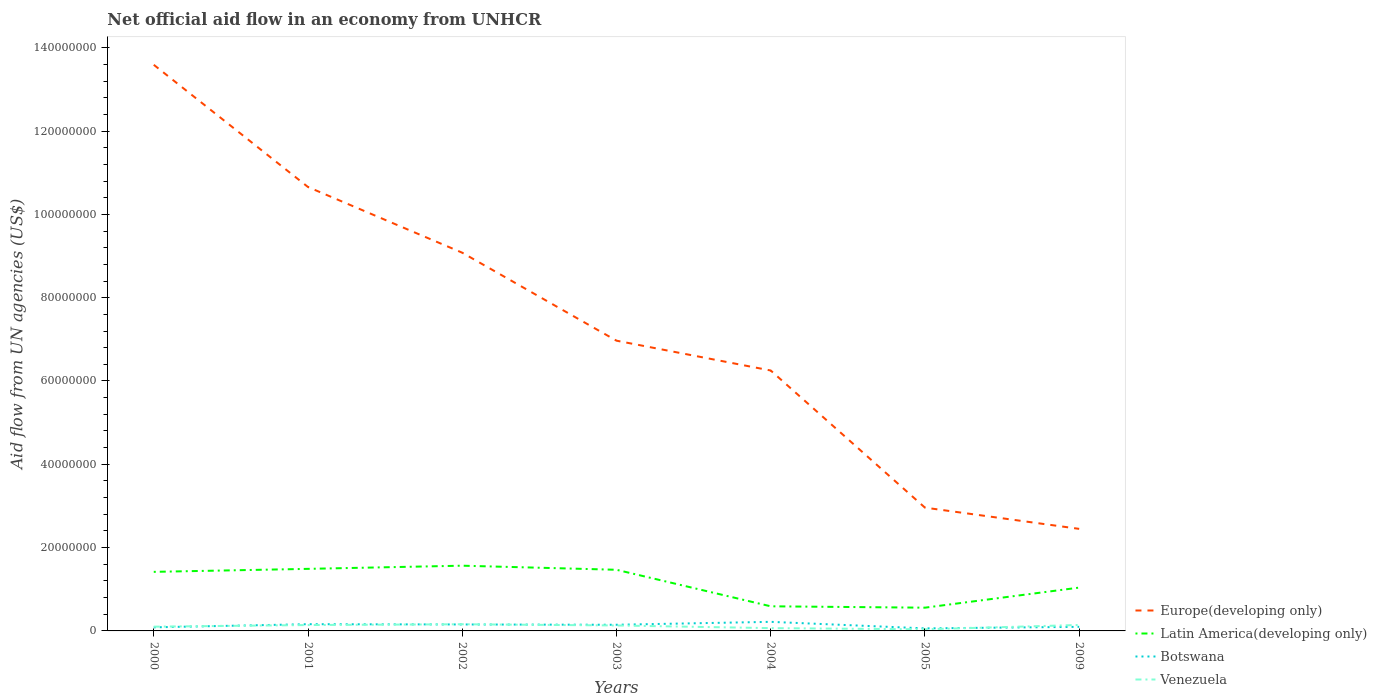How many different coloured lines are there?
Give a very brief answer. 4. Is the number of lines equal to the number of legend labels?
Provide a succinct answer. Yes. What is the total net official aid flow in Venezuela in the graph?
Ensure brevity in your answer.  1.21e+06. What is the difference between the highest and the second highest net official aid flow in Europe(developing only)?
Provide a short and direct response. 1.11e+08. What is the difference between the highest and the lowest net official aid flow in Europe(developing only)?
Offer a very short reply. 3. How many lines are there?
Provide a succinct answer. 4. What is the difference between two consecutive major ticks on the Y-axis?
Make the answer very short. 2.00e+07. Are the values on the major ticks of Y-axis written in scientific E-notation?
Make the answer very short. No. Does the graph contain any zero values?
Your answer should be compact. No. Does the graph contain grids?
Offer a very short reply. No. Where does the legend appear in the graph?
Ensure brevity in your answer.  Bottom right. How many legend labels are there?
Make the answer very short. 4. What is the title of the graph?
Your response must be concise. Net official aid flow in an economy from UNHCR. Does "Uzbekistan" appear as one of the legend labels in the graph?
Provide a succinct answer. No. What is the label or title of the X-axis?
Offer a very short reply. Years. What is the label or title of the Y-axis?
Keep it short and to the point. Aid flow from UN agencies (US$). What is the Aid flow from UN agencies (US$) of Europe(developing only) in 2000?
Your answer should be compact. 1.36e+08. What is the Aid flow from UN agencies (US$) of Latin America(developing only) in 2000?
Offer a very short reply. 1.42e+07. What is the Aid flow from UN agencies (US$) in Botswana in 2000?
Your answer should be compact. 8.60e+05. What is the Aid flow from UN agencies (US$) of Venezuela in 2000?
Keep it short and to the point. 1.02e+06. What is the Aid flow from UN agencies (US$) of Europe(developing only) in 2001?
Offer a terse response. 1.07e+08. What is the Aid flow from UN agencies (US$) in Latin America(developing only) in 2001?
Offer a very short reply. 1.49e+07. What is the Aid flow from UN agencies (US$) in Botswana in 2001?
Your response must be concise. 1.62e+06. What is the Aid flow from UN agencies (US$) of Venezuela in 2001?
Your response must be concise. 1.41e+06. What is the Aid flow from UN agencies (US$) in Europe(developing only) in 2002?
Make the answer very short. 9.08e+07. What is the Aid flow from UN agencies (US$) in Latin America(developing only) in 2002?
Offer a terse response. 1.57e+07. What is the Aid flow from UN agencies (US$) in Botswana in 2002?
Ensure brevity in your answer.  1.55e+06. What is the Aid flow from UN agencies (US$) of Venezuela in 2002?
Ensure brevity in your answer.  1.60e+06. What is the Aid flow from UN agencies (US$) of Europe(developing only) in 2003?
Your answer should be very brief. 6.97e+07. What is the Aid flow from UN agencies (US$) of Latin America(developing only) in 2003?
Keep it short and to the point. 1.47e+07. What is the Aid flow from UN agencies (US$) of Botswana in 2003?
Ensure brevity in your answer.  1.48e+06. What is the Aid flow from UN agencies (US$) in Venezuela in 2003?
Offer a very short reply. 1.31e+06. What is the Aid flow from UN agencies (US$) of Europe(developing only) in 2004?
Give a very brief answer. 6.25e+07. What is the Aid flow from UN agencies (US$) in Latin America(developing only) in 2004?
Offer a terse response. 5.91e+06. What is the Aid flow from UN agencies (US$) in Botswana in 2004?
Give a very brief answer. 2.18e+06. What is the Aid flow from UN agencies (US$) in Venezuela in 2004?
Provide a short and direct response. 6.70e+05. What is the Aid flow from UN agencies (US$) in Europe(developing only) in 2005?
Keep it short and to the point. 2.96e+07. What is the Aid flow from UN agencies (US$) in Latin America(developing only) in 2005?
Provide a succinct answer. 5.58e+06. What is the Aid flow from UN agencies (US$) of Europe(developing only) in 2009?
Your answer should be very brief. 2.45e+07. What is the Aid flow from UN agencies (US$) of Latin America(developing only) in 2009?
Provide a succinct answer. 1.04e+07. What is the Aid flow from UN agencies (US$) in Botswana in 2009?
Provide a short and direct response. 9.80e+05. What is the Aid flow from UN agencies (US$) in Venezuela in 2009?
Ensure brevity in your answer.  1.43e+06. Across all years, what is the maximum Aid flow from UN agencies (US$) in Europe(developing only)?
Your answer should be compact. 1.36e+08. Across all years, what is the maximum Aid flow from UN agencies (US$) of Latin America(developing only)?
Ensure brevity in your answer.  1.57e+07. Across all years, what is the maximum Aid flow from UN agencies (US$) of Botswana?
Keep it short and to the point. 2.18e+06. Across all years, what is the maximum Aid flow from UN agencies (US$) in Venezuela?
Provide a succinct answer. 1.60e+06. Across all years, what is the minimum Aid flow from UN agencies (US$) of Europe(developing only)?
Provide a succinct answer. 2.45e+07. Across all years, what is the minimum Aid flow from UN agencies (US$) in Latin America(developing only)?
Provide a succinct answer. 5.58e+06. Across all years, what is the minimum Aid flow from UN agencies (US$) in Botswana?
Keep it short and to the point. 6.10e+05. What is the total Aid flow from UN agencies (US$) in Europe(developing only) in the graph?
Provide a short and direct response. 5.20e+08. What is the total Aid flow from UN agencies (US$) in Latin America(developing only) in the graph?
Your answer should be very brief. 8.13e+07. What is the total Aid flow from UN agencies (US$) in Botswana in the graph?
Offer a terse response. 9.28e+06. What is the total Aid flow from UN agencies (US$) of Venezuela in the graph?
Provide a short and direct response. 7.83e+06. What is the difference between the Aid flow from UN agencies (US$) in Europe(developing only) in 2000 and that in 2001?
Offer a terse response. 2.93e+07. What is the difference between the Aid flow from UN agencies (US$) of Latin America(developing only) in 2000 and that in 2001?
Your response must be concise. -7.20e+05. What is the difference between the Aid flow from UN agencies (US$) of Botswana in 2000 and that in 2001?
Offer a terse response. -7.60e+05. What is the difference between the Aid flow from UN agencies (US$) in Venezuela in 2000 and that in 2001?
Offer a very short reply. -3.90e+05. What is the difference between the Aid flow from UN agencies (US$) in Europe(developing only) in 2000 and that in 2002?
Your response must be concise. 4.51e+07. What is the difference between the Aid flow from UN agencies (US$) of Latin America(developing only) in 2000 and that in 2002?
Provide a succinct answer. -1.48e+06. What is the difference between the Aid flow from UN agencies (US$) of Botswana in 2000 and that in 2002?
Make the answer very short. -6.90e+05. What is the difference between the Aid flow from UN agencies (US$) in Venezuela in 2000 and that in 2002?
Ensure brevity in your answer.  -5.80e+05. What is the difference between the Aid flow from UN agencies (US$) in Europe(developing only) in 2000 and that in 2003?
Offer a terse response. 6.62e+07. What is the difference between the Aid flow from UN agencies (US$) in Latin America(developing only) in 2000 and that in 2003?
Give a very brief answer. -5.00e+05. What is the difference between the Aid flow from UN agencies (US$) in Botswana in 2000 and that in 2003?
Provide a short and direct response. -6.20e+05. What is the difference between the Aid flow from UN agencies (US$) of Europe(developing only) in 2000 and that in 2004?
Make the answer very short. 7.34e+07. What is the difference between the Aid flow from UN agencies (US$) in Latin America(developing only) in 2000 and that in 2004?
Provide a succinct answer. 8.27e+06. What is the difference between the Aid flow from UN agencies (US$) in Botswana in 2000 and that in 2004?
Provide a succinct answer. -1.32e+06. What is the difference between the Aid flow from UN agencies (US$) in Venezuela in 2000 and that in 2004?
Provide a succinct answer. 3.50e+05. What is the difference between the Aid flow from UN agencies (US$) of Europe(developing only) in 2000 and that in 2005?
Offer a terse response. 1.06e+08. What is the difference between the Aid flow from UN agencies (US$) of Latin America(developing only) in 2000 and that in 2005?
Your answer should be very brief. 8.60e+06. What is the difference between the Aid flow from UN agencies (US$) in Botswana in 2000 and that in 2005?
Keep it short and to the point. 2.50e+05. What is the difference between the Aid flow from UN agencies (US$) in Venezuela in 2000 and that in 2005?
Your answer should be very brief. 6.30e+05. What is the difference between the Aid flow from UN agencies (US$) in Europe(developing only) in 2000 and that in 2009?
Your answer should be compact. 1.11e+08. What is the difference between the Aid flow from UN agencies (US$) in Latin America(developing only) in 2000 and that in 2009?
Your answer should be compact. 3.78e+06. What is the difference between the Aid flow from UN agencies (US$) in Venezuela in 2000 and that in 2009?
Provide a short and direct response. -4.10e+05. What is the difference between the Aid flow from UN agencies (US$) of Europe(developing only) in 2001 and that in 2002?
Provide a short and direct response. 1.58e+07. What is the difference between the Aid flow from UN agencies (US$) of Latin America(developing only) in 2001 and that in 2002?
Your response must be concise. -7.60e+05. What is the difference between the Aid flow from UN agencies (US$) in Botswana in 2001 and that in 2002?
Provide a short and direct response. 7.00e+04. What is the difference between the Aid flow from UN agencies (US$) of Europe(developing only) in 2001 and that in 2003?
Make the answer very short. 3.69e+07. What is the difference between the Aid flow from UN agencies (US$) in Latin America(developing only) in 2001 and that in 2003?
Provide a short and direct response. 2.20e+05. What is the difference between the Aid flow from UN agencies (US$) of Botswana in 2001 and that in 2003?
Provide a succinct answer. 1.40e+05. What is the difference between the Aid flow from UN agencies (US$) of Europe(developing only) in 2001 and that in 2004?
Ensure brevity in your answer.  4.40e+07. What is the difference between the Aid flow from UN agencies (US$) of Latin America(developing only) in 2001 and that in 2004?
Provide a short and direct response. 8.99e+06. What is the difference between the Aid flow from UN agencies (US$) of Botswana in 2001 and that in 2004?
Your response must be concise. -5.60e+05. What is the difference between the Aid flow from UN agencies (US$) of Venezuela in 2001 and that in 2004?
Offer a very short reply. 7.40e+05. What is the difference between the Aid flow from UN agencies (US$) of Europe(developing only) in 2001 and that in 2005?
Ensure brevity in your answer.  7.70e+07. What is the difference between the Aid flow from UN agencies (US$) of Latin America(developing only) in 2001 and that in 2005?
Ensure brevity in your answer.  9.32e+06. What is the difference between the Aid flow from UN agencies (US$) in Botswana in 2001 and that in 2005?
Provide a short and direct response. 1.01e+06. What is the difference between the Aid flow from UN agencies (US$) in Venezuela in 2001 and that in 2005?
Ensure brevity in your answer.  1.02e+06. What is the difference between the Aid flow from UN agencies (US$) of Europe(developing only) in 2001 and that in 2009?
Offer a very short reply. 8.21e+07. What is the difference between the Aid flow from UN agencies (US$) of Latin America(developing only) in 2001 and that in 2009?
Your answer should be very brief. 4.50e+06. What is the difference between the Aid flow from UN agencies (US$) in Botswana in 2001 and that in 2009?
Offer a very short reply. 6.40e+05. What is the difference between the Aid flow from UN agencies (US$) in Europe(developing only) in 2002 and that in 2003?
Provide a short and direct response. 2.11e+07. What is the difference between the Aid flow from UN agencies (US$) of Latin America(developing only) in 2002 and that in 2003?
Your response must be concise. 9.80e+05. What is the difference between the Aid flow from UN agencies (US$) in Botswana in 2002 and that in 2003?
Give a very brief answer. 7.00e+04. What is the difference between the Aid flow from UN agencies (US$) in Europe(developing only) in 2002 and that in 2004?
Keep it short and to the point. 2.83e+07. What is the difference between the Aid flow from UN agencies (US$) of Latin America(developing only) in 2002 and that in 2004?
Your response must be concise. 9.75e+06. What is the difference between the Aid flow from UN agencies (US$) of Botswana in 2002 and that in 2004?
Provide a short and direct response. -6.30e+05. What is the difference between the Aid flow from UN agencies (US$) of Venezuela in 2002 and that in 2004?
Your answer should be very brief. 9.30e+05. What is the difference between the Aid flow from UN agencies (US$) of Europe(developing only) in 2002 and that in 2005?
Your answer should be very brief. 6.12e+07. What is the difference between the Aid flow from UN agencies (US$) in Latin America(developing only) in 2002 and that in 2005?
Your answer should be very brief. 1.01e+07. What is the difference between the Aid flow from UN agencies (US$) in Botswana in 2002 and that in 2005?
Your answer should be very brief. 9.40e+05. What is the difference between the Aid flow from UN agencies (US$) of Venezuela in 2002 and that in 2005?
Provide a succinct answer. 1.21e+06. What is the difference between the Aid flow from UN agencies (US$) in Europe(developing only) in 2002 and that in 2009?
Provide a short and direct response. 6.63e+07. What is the difference between the Aid flow from UN agencies (US$) in Latin America(developing only) in 2002 and that in 2009?
Make the answer very short. 5.26e+06. What is the difference between the Aid flow from UN agencies (US$) in Botswana in 2002 and that in 2009?
Provide a short and direct response. 5.70e+05. What is the difference between the Aid flow from UN agencies (US$) of Venezuela in 2002 and that in 2009?
Your answer should be very brief. 1.70e+05. What is the difference between the Aid flow from UN agencies (US$) in Europe(developing only) in 2003 and that in 2004?
Offer a very short reply. 7.16e+06. What is the difference between the Aid flow from UN agencies (US$) of Latin America(developing only) in 2003 and that in 2004?
Make the answer very short. 8.77e+06. What is the difference between the Aid flow from UN agencies (US$) of Botswana in 2003 and that in 2004?
Your answer should be compact. -7.00e+05. What is the difference between the Aid flow from UN agencies (US$) in Venezuela in 2003 and that in 2004?
Offer a terse response. 6.40e+05. What is the difference between the Aid flow from UN agencies (US$) in Europe(developing only) in 2003 and that in 2005?
Offer a terse response. 4.01e+07. What is the difference between the Aid flow from UN agencies (US$) of Latin America(developing only) in 2003 and that in 2005?
Provide a short and direct response. 9.10e+06. What is the difference between the Aid flow from UN agencies (US$) in Botswana in 2003 and that in 2005?
Make the answer very short. 8.70e+05. What is the difference between the Aid flow from UN agencies (US$) in Venezuela in 2003 and that in 2005?
Make the answer very short. 9.20e+05. What is the difference between the Aid flow from UN agencies (US$) of Europe(developing only) in 2003 and that in 2009?
Your answer should be very brief. 4.52e+07. What is the difference between the Aid flow from UN agencies (US$) in Latin America(developing only) in 2003 and that in 2009?
Give a very brief answer. 4.28e+06. What is the difference between the Aid flow from UN agencies (US$) of Botswana in 2003 and that in 2009?
Your answer should be very brief. 5.00e+05. What is the difference between the Aid flow from UN agencies (US$) of Europe(developing only) in 2004 and that in 2005?
Offer a terse response. 3.29e+07. What is the difference between the Aid flow from UN agencies (US$) in Botswana in 2004 and that in 2005?
Keep it short and to the point. 1.57e+06. What is the difference between the Aid flow from UN agencies (US$) in Europe(developing only) in 2004 and that in 2009?
Give a very brief answer. 3.80e+07. What is the difference between the Aid flow from UN agencies (US$) of Latin America(developing only) in 2004 and that in 2009?
Your response must be concise. -4.49e+06. What is the difference between the Aid flow from UN agencies (US$) in Botswana in 2004 and that in 2009?
Your response must be concise. 1.20e+06. What is the difference between the Aid flow from UN agencies (US$) of Venezuela in 2004 and that in 2009?
Make the answer very short. -7.60e+05. What is the difference between the Aid flow from UN agencies (US$) of Europe(developing only) in 2005 and that in 2009?
Provide a short and direct response. 5.10e+06. What is the difference between the Aid flow from UN agencies (US$) in Latin America(developing only) in 2005 and that in 2009?
Give a very brief answer. -4.82e+06. What is the difference between the Aid flow from UN agencies (US$) in Botswana in 2005 and that in 2009?
Your answer should be compact. -3.70e+05. What is the difference between the Aid flow from UN agencies (US$) in Venezuela in 2005 and that in 2009?
Provide a succinct answer. -1.04e+06. What is the difference between the Aid flow from UN agencies (US$) of Europe(developing only) in 2000 and the Aid flow from UN agencies (US$) of Latin America(developing only) in 2001?
Make the answer very short. 1.21e+08. What is the difference between the Aid flow from UN agencies (US$) in Europe(developing only) in 2000 and the Aid flow from UN agencies (US$) in Botswana in 2001?
Ensure brevity in your answer.  1.34e+08. What is the difference between the Aid flow from UN agencies (US$) in Europe(developing only) in 2000 and the Aid flow from UN agencies (US$) in Venezuela in 2001?
Your response must be concise. 1.34e+08. What is the difference between the Aid flow from UN agencies (US$) in Latin America(developing only) in 2000 and the Aid flow from UN agencies (US$) in Botswana in 2001?
Provide a succinct answer. 1.26e+07. What is the difference between the Aid flow from UN agencies (US$) in Latin America(developing only) in 2000 and the Aid flow from UN agencies (US$) in Venezuela in 2001?
Keep it short and to the point. 1.28e+07. What is the difference between the Aid flow from UN agencies (US$) of Botswana in 2000 and the Aid flow from UN agencies (US$) of Venezuela in 2001?
Your answer should be very brief. -5.50e+05. What is the difference between the Aid flow from UN agencies (US$) in Europe(developing only) in 2000 and the Aid flow from UN agencies (US$) in Latin America(developing only) in 2002?
Offer a terse response. 1.20e+08. What is the difference between the Aid flow from UN agencies (US$) in Europe(developing only) in 2000 and the Aid flow from UN agencies (US$) in Botswana in 2002?
Give a very brief answer. 1.34e+08. What is the difference between the Aid flow from UN agencies (US$) of Europe(developing only) in 2000 and the Aid flow from UN agencies (US$) of Venezuela in 2002?
Keep it short and to the point. 1.34e+08. What is the difference between the Aid flow from UN agencies (US$) of Latin America(developing only) in 2000 and the Aid flow from UN agencies (US$) of Botswana in 2002?
Your response must be concise. 1.26e+07. What is the difference between the Aid flow from UN agencies (US$) of Latin America(developing only) in 2000 and the Aid flow from UN agencies (US$) of Venezuela in 2002?
Your response must be concise. 1.26e+07. What is the difference between the Aid flow from UN agencies (US$) of Botswana in 2000 and the Aid flow from UN agencies (US$) of Venezuela in 2002?
Give a very brief answer. -7.40e+05. What is the difference between the Aid flow from UN agencies (US$) in Europe(developing only) in 2000 and the Aid flow from UN agencies (US$) in Latin America(developing only) in 2003?
Offer a terse response. 1.21e+08. What is the difference between the Aid flow from UN agencies (US$) of Europe(developing only) in 2000 and the Aid flow from UN agencies (US$) of Botswana in 2003?
Provide a short and direct response. 1.34e+08. What is the difference between the Aid flow from UN agencies (US$) in Europe(developing only) in 2000 and the Aid flow from UN agencies (US$) in Venezuela in 2003?
Ensure brevity in your answer.  1.35e+08. What is the difference between the Aid flow from UN agencies (US$) of Latin America(developing only) in 2000 and the Aid flow from UN agencies (US$) of Botswana in 2003?
Your answer should be very brief. 1.27e+07. What is the difference between the Aid flow from UN agencies (US$) in Latin America(developing only) in 2000 and the Aid flow from UN agencies (US$) in Venezuela in 2003?
Offer a terse response. 1.29e+07. What is the difference between the Aid flow from UN agencies (US$) of Botswana in 2000 and the Aid flow from UN agencies (US$) of Venezuela in 2003?
Your response must be concise. -4.50e+05. What is the difference between the Aid flow from UN agencies (US$) in Europe(developing only) in 2000 and the Aid flow from UN agencies (US$) in Latin America(developing only) in 2004?
Your response must be concise. 1.30e+08. What is the difference between the Aid flow from UN agencies (US$) in Europe(developing only) in 2000 and the Aid flow from UN agencies (US$) in Botswana in 2004?
Make the answer very short. 1.34e+08. What is the difference between the Aid flow from UN agencies (US$) of Europe(developing only) in 2000 and the Aid flow from UN agencies (US$) of Venezuela in 2004?
Ensure brevity in your answer.  1.35e+08. What is the difference between the Aid flow from UN agencies (US$) of Latin America(developing only) in 2000 and the Aid flow from UN agencies (US$) of Venezuela in 2004?
Provide a succinct answer. 1.35e+07. What is the difference between the Aid flow from UN agencies (US$) of Botswana in 2000 and the Aid flow from UN agencies (US$) of Venezuela in 2004?
Offer a terse response. 1.90e+05. What is the difference between the Aid flow from UN agencies (US$) of Europe(developing only) in 2000 and the Aid flow from UN agencies (US$) of Latin America(developing only) in 2005?
Your answer should be compact. 1.30e+08. What is the difference between the Aid flow from UN agencies (US$) of Europe(developing only) in 2000 and the Aid flow from UN agencies (US$) of Botswana in 2005?
Your answer should be compact. 1.35e+08. What is the difference between the Aid flow from UN agencies (US$) of Europe(developing only) in 2000 and the Aid flow from UN agencies (US$) of Venezuela in 2005?
Offer a terse response. 1.36e+08. What is the difference between the Aid flow from UN agencies (US$) of Latin America(developing only) in 2000 and the Aid flow from UN agencies (US$) of Botswana in 2005?
Your response must be concise. 1.36e+07. What is the difference between the Aid flow from UN agencies (US$) in Latin America(developing only) in 2000 and the Aid flow from UN agencies (US$) in Venezuela in 2005?
Ensure brevity in your answer.  1.38e+07. What is the difference between the Aid flow from UN agencies (US$) in Europe(developing only) in 2000 and the Aid flow from UN agencies (US$) in Latin America(developing only) in 2009?
Your response must be concise. 1.26e+08. What is the difference between the Aid flow from UN agencies (US$) of Europe(developing only) in 2000 and the Aid flow from UN agencies (US$) of Botswana in 2009?
Give a very brief answer. 1.35e+08. What is the difference between the Aid flow from UN agencies (US$) of Europe(developing only) in 2000 and the Aid flow from UN agencies (US$) of Venezuela in 2009?
Provide a succinct answer. 1.34e+08. What is the difference between the Aid flow from UN agencies (US$) in Latin America(developing only) in 2000 and the Aid flow from UN agencies (US$) in Botswana in 2009?
Offer a very short reply. 1.32e+07. What is the difference between the Aid flow from UN agencies (US$) of Latin America(developing only) in 2000 and the Aid flow from UN agencies (US$) of Venezuela in 2009?
Give a very brief answer. 1.28e+07. What is the difference between the Aid flow from UN agencies (US$) of Botswana in 2000 and the Aid flow from UN agencies (US$) of Venezuela in 2009?
Keep it short and to the point. -5.70e+05. What is the difference between the Aid flow from UN agencies (US$) of Europe(developing only) in 2001 and the Aid flow from UN agencies (US$) of Latin America(developing only) in 2002?
Provide a succinct answer. 9.09e+07. What is the difference between the Aid flow from UN agencies (US$) of Europe(developing only) in 2001 and the Aid flow from UN agencies (US$) of Botswana in 2002?
Give a very brief answer. 1.05e+08. What is the difference between the Aid flow from UN agencies (US$) of Europe(developing only) in 2001 and the Aid flow from UN agencies (US$) of Venezuela in 2002?
Give a very brief answer. 1.05e+08. What is the difference between the Aid flow from UN agencies (US$) of Latin America(developing only) in 2001 and the Aid flow from UN agencies (US$) of Botswana in 2002?
Ensure brevity in your answer.  1.34e+07. What is the difference between the Aid flow from UN agencies (US$) of Latin America(developing only) in 2001 and the Aid flow from UN agencies (US$) of Venezuela in 2002?
Offer a terse response. 1.33e+07. What is the difference between the Aid flow from UN agencies (US$) of Europe(developing only) in 2001 and the Aid flow from UN agencies (US$) of Latin America(developing only) in 2003?
Offer a very short reply. 9.19e+07. What is the difference between the Aid flow from UN agencies (US$) of Europe(developing only) in 2001 and the Aid flow from UN agencies (US$) of Botswana in 2003?
Offer a very short reply. 1.05e+08. What is the difference between the Aid flow from UN agencies (US$) of Europe(developing only) in 2001 and the Aid flow from UN agencies (US$) of Venezuela in 2003?
Offer a terse response. 1.05e+08. What is the difference between the Aid flow from UN agencies (US$) of Latin America(developing only) in 2001 and the Aid flow from UN agencies (US$) of Botswana in 2003?
Ensure brevity in your answer.  1.34e+07. What is the difference between the Aid flow from UN agencies (US$) of Latin America(developing only) in 2001 and the Aid flow from UN agencies (US$) of Venezuela in 2003?
Your answer should be compact. 1.36e+07. What is the difference between the Aid flow from UN agencies (US$) of Botswana in 2001 and the Aid flow from UN agencies (US$) of Venezuela in 2003?
Provide a succinct answer. 3.10e+05. What is the difference between the Aid flow from UN agencies (US$) in Europe(developing only) in 2001 and the Aid flow from UN agencies (US$) in Latin America(developing only) in 2004?
Your response must be concise. 1.01e+08. What is the difference between the Aid flow from UN agencies (US$) in Europe(developing only) in 2001 and the Aid flow from UN agencies (US$) in Botswana in 2004?
Provide a short and direct response. 1.04e+08. What is the difference between the Aid flow from UN agencies (US$) of Europe(developing only) in 2001 and the Aid flow from UN agencies (US$) of Venezuela in 2004?
Offer a very short reply. 1.06e+08. What is the difference between the Aid flow from UN agencies (US$) of Latin America(developing only) in 2001 and the Aid flow from UN agencies (US$) of Botswana in 2004?
Offer a terse response. 1.27e+07. What is the difference between the Aid flow from UN agencies (US$) of Latin America(developing only) in 2001 and the Aid flow from UN agencies (US$) of Venezuela in 2004?
Offer a terse response. 1.42e+07. What is the difference between the Aid flow from UN agencies (US$) in Botswana in 2001 and the Aid flow from UN agencies (US$) in Venezuela in 2004?
Provide a succinct answer. 9.50e+05. What is the difference between the Aid flow from UN agencies (US$) in Europe(developing only) in 2001 and the Aid flow from UN agencies (US$) in Latin America(developing only) in 2005?
Make the answer very short. 1.01e+08. What is the difference between the Aid flow from UN agencies (US$) of Europe(developing only) in 2001 and the Aid flow from UN agencies (US$) of Botswana in 2005?
Your response must be concise. 1.06e+08. What is the difference between the Aid flow from UN agencies (US$) of Europe(developing only) in 2001 and the Aid flow from UN agencies (US$) of Venezuela in 2005?
Offer a terse response. 1.06e+08. What is the difference between the Aid flow from UN agencies (US$) in Latin America(developing only) in 2001 and the Aid flow from UN agencies (US$) in Botswana in 2005?
Provide a succinct answer. 1.43e+07. What is the difference between the Aid flow from UN agencies (US$) of Latin America(developing only) in 2001 and the Aid flow from UN agencies (US$) of Venezuela in 2005?
Keep it short and to the point. 1.45e+07. What is the difference between the Aid flow from UN agencies (US$) in Botswana in 2001 and the Aid flow from UN agencies (US$) in Venezuela in 2005?
Ensure brevity in your answer.  1.23e+06. What is the difference between the Aid flow from UN agencies (US$) of Europe(developing only) in 2001 and the Aid flow from UN agencies (US$) of Latin America(developing only) in 2009?
Provide a succinct answer. 9.62e+07. What is the difference between the Aid flow from UN agencies (US$) in Europe(developing only) in 2001 and the Aid flow from UN agencies (US$) in Botswana in 2009?
Provide a succinct answer. 1.06e+08. What is the difference between the Aid flow from UN agencies (US$) of Europe(developing only) in 2001 and the Aid flow from UN agencies (US$) of Venezuela in 2009?
Your answer should be very brief. 1.05e+08. What is the difference between the Aid flow from UN agencies (US$) of Latin America(developing only) in 2001 and the Aid flow from UN agencies (US$) of Botswana in 2009?
Give a very brief answer. 1.39e+07. What is the difference between the Aid flow from UN agencies (US$) in Latin America(developing only) in 2001 and the Aid flow from UN agencies (US$) in Venezuela in 2009?
Offer a very short reply. 1.35e+07. What is the difference between the Aid flow from UN agencies (US$) of Europe(developing only) in 2002 and the Aid flow from UN agencies (US$) of Latin America(developing only) in 2003?
Your answer should be very brief. 7.61e+07. What is the difference between the Aid flow from UN agencies (US$) of Europe(developing only) in 2002 and the Aid flow from UN agencies (US$) of Botswana in 2003?
Provide a short and direct response. 8.93e+07. What is the difference between the Aid flow from UN agencies (US$) of Europe(developing only) in 2002 and the Aid flow from UN agencies (US$) of Venezuela in 2003?
Your response must be concise. 8.95e+07. What is the difference between the Aid flow from UN agencies (US$) in Latin America(developing only) in 2002 and the Aid flow from UN agencies (US$) in Botswana in 2003?
Make the answer very short. 1.42e+07. What is the difference between the Aid flow from UN agencies (US$) in Latin America(developing only) in 2002 and the Aid flow from UN agencies (US$) in Venezuela in 2003?
Provide a succinct answer. 1.44e+07. What is the difference between the Aid flow from UN agencies (US$) in Botswana in 2002 and the Aid flow from UN agencies (US$) in Venezuela in 2003?
Offer a terse response. 2.40e+05. What is the difference between the Aid flow from UN agencies (US$) in Europe(developing only) in 2002 and the Aid flow from UN agencies (US$) in Latin America(developing only) in 2004?
Offer a terse response. 8.49e+07. What is the difference between the Aid flow from UN agencies (US$) of Europe(developing only) in 2002 and the Aid flow from UN agencies (US$) of Botswana in 2004?
Make the answer very short. 8.86e+07. What is the difference between the Aid flow from UN agencies (US$) in Europe(developing only) in 2002 and the Aid flow from UN agencies (US$) in Venezuela in 2004?
Provide a short and direct response. 9.01e+07. What is the difference between the Aid flow from UN agencies (US$) of Latin America(developing only) in 2002 and the Aid flow from UN agencies (US$) of Botswana in 2004?
Your answer should be very brief. 1.35e+07. What is the difference between the Aid flow from UN agencies (US$) of Latin America(developing only) in 2002 and the Aid flow from UN agencies (US$) of Venezuela in 2004?
Give a very brief answer. 1.50e+07. What is the difference between the Aid flow from UN agencies (US$) in Botswana in 2002 and the Aid flow from UN agencies (US$) in Venezuela in 2004?
Your answer should be very brief. 8.80e+05. What is the difference between the Aid flow from UN agencies (US$) in Europe(developing only) in 2002 and the Aid flow from UN agencies (US$) in Latin America(developing only) in 2005?
Your answer should be compact. 8.52e+07. What is the difference between the Aid flow from UN agencies (US$) of Europe(developing only) in 2002 and the Aid flow from UN agencies (US$) of Botswana in 2005?
Ensure brevity in your answer.  9.02e+07. What is the difference between the Aid flow from UN agencies (US$) of Europe(developing only) in 2002 and the Aid flow from UN agencies (US$) of Venezuela in 2005?
Keep it short and to the point. 9.04e+07. What is the difference between the Aid flow from UN agencies (US$) in Latin America(developing only) in 2002 and the Aid flow from UN agencies (US$) in Botswana in 2005?
Give a very brief answer. 1.50e+07. What is the difference between the Aid flow from UN agencies (US$) of Latin America(developing only) in 2002 and the Aid flow from UN agencies (US$) of Venezuela in 2005?
Provide a short and direct response. 1.53e+07. What is the difference between the Aid flow from UN agencies (US$) in Botswana in 2002 and the Aid flow from UN agencies (US$) in Venezuela in 2005?
Provide a short and direct response. 1.16e+06. What is the difference between the Aid flow from UN agencies (US$) of Europe(developing only) in 2002 and the Aid flow from UN agencies (US$) of Latin America(developing only) in 2009?
Your answer should be very brief. 8.04e+07. What is the difference between the Aid flow from UN agencies (US$) of Europe(developing only) in 2002 and the Aid flow from UN agencies (US$) of Botswana in 2009?
Keep it short and to the point. 8.98e+07. What is the difference between the Aid flow from UN agencies (US$) in Europe(developing only) in 2002 and the Aid flow from UN agencies (US$) in Venezuela in 2009?
Provide a succinct answer. 8.94e+07. What is the difference between the Aid flow from UN agencies (US$) in Latin America(developing only) in 2002 and the Aid flow from UN agencies (US$) in Botswana in 2009?
Ensure brevity in your answer.  1.47e+07. What is the difference between the Aid flow from UN agencies (US$) in Latin America(developing only) in 2002 and the Aid flow from UN agencies (US$) in Venezuela in 2009?
Your response must be concise. 1.42e+07. What is the difference between the Aid flow from UN agencies (US$) of Botswana in 2002 and the Aid flow from UN agencies (US$) of Venezuela in 2009?
Give a very brief answer. 1.20e+05. What is the difference between the Aid flow from UN agencies (US$) of Europe(developing only) in 2003 and the Aid flow from UN agencies (US$) of Latin America(developing only) in 2004?
Make the answer very short. 6.38e+07. What is the difference between the Aid flow from UN agencies (US$) in Europe(developing only) in 2003 and the Aid flow from UN agencies (US$) in Botswana in 2004?
Ensure brevity in your answer.  6.75e+07. What is the difference between the Aid flow from UN agencies (US$) in Europe(developing only) in 2003 and the Aid flow from UN agencies (US$) in Venezuela in 2004?
Provide a short and direct response. 6.90e+07. What is the difference between the Aid flow from UN agencies (US$) in Latin America(developing only) in 2003 and the Aid flow from UN agencies (US$) in Botswana in 2004?
Ensure brevity in your answer.  1.25e+07. What is the difference between the Aid flow from UN agencies (US$) of Latin America(developing only) in 2003 and the Aid flow from UN agencies (US$) of Venezuela in 2004?
Provide a short and direct response. 1.40e+07. What is the difference between the Aid flow from UN agencies (US$) in Botswana in 2003 and the Aid flow from UN agencies (US$) in Venezuela in 2004?
Keep it short and to the point. 8.10e+05. What is the difference between the Aid flow from UN agencies (US$) of Europe(developing only) in 2003 and the Aid flow from UN agencies (US$) of Latin America(developing only) in 2005?
Offer a very short reply. 6.41e+07. What is the difference between the Aid flow from UN agencies (US$) in Europe(developing only) in 2003 and the Aid flow from UN agencies (US$) in Botswana in 2005?
Provide a succinct answer. 6.91e+07. What is the difference between the Aid flow from UN agencies (US$) of Europe(developing only) in 2003 and the Aid flow from UN agencies (US$) of Venezuela in 2005?
Keep it short and to the point. 6.93e+07. What is the difference between the Aid flow from UN agencies (US$) in Latin America(developing only) in 2003 and the Aid flow from UN agencies (US$) in Botswana in 2005?
Ensure brevity in your answer.  1.41e+07. What is the difference between the Aid flow from UN agencies (US$) of Latin America(developing only) in 2003 and the Aid flow from UN agencies (US$) of Venezuela in 2005?
Provide a succinct answer. 1.43e+07. What is the difference between the Aid flow from UN agencies (US$) in Botswana in 2003 and the Aid flow from UN agencies (US$) in Venezuela in 2005?
Your answer should be very brief. 1.09e+06. What is the difference between the Aid flow from UN agencies (US$) in Europe(developing only) in 2003 and the Aid flow from UN agencies (US$) in Latin America(developing only) in 2009?
Make the answer very short. 5.93e+07. What is the difference between the Aid flow from UN agencies (US$) of Europe(developing only) in 2003 and the Aid flow from UN agencies (US$) of Botswana in 2009?
Make the answer very short. 6.87e+07. What is the difference between the Aid flow from UN agencies (US$) in Europe(developing only) in 2003 and the Aid flow from UN agencies (US$) in Venezuela in 2009?
Provide a succinct answer. 6.82e+07. What is the difference between the Aid flow from UN agencies (US$) of Latin America(developing only) in 2003 and the Aid flow from UN agencies (US$) of Botswana in 2009?
Provide a short and direct response. 1.37e+07. What is the difference between the Aid flow from UN agencies (US$) of Latin America(developing only) in 2003 and the Aid flow from UN agencies (US$) of Venezuela in 2009?
Give a very brief answer. 1.32e+07. What is the difference between the Aid flow from UN agencies (US$) of Botswana in 2003 and the Aid flow from UN agencies (US$) of Venezuela in 2009?
Provide a short and direct response. 5.00e+04. What is the difference between the Aid flow from UN agencies (US$) in Europe(developing only) in 2004 and the Aid flow from UN agencies (US$) in Latin America(developing only) in 2005?
Offer a terse response. 5.69e+07. What is the difference between the Aid flow from UN agencies (US$) in Europe(developing only) in 2004 and the Aid flow from UN agencies (US$) in Botswana in 2005?
Give a very brief answer. 6.19e+07. What is the difference between the Aid flow from UN agencies (US$) of Europe(developing only) in 2004 and the Aid flow from UN agencies (US$) of Venezuela in 2005?
Your response must be concise. 6.21e+07. What is the difference between the Aid flow from UN agencies (US$) of Latin America(developing only) in 2004 and the Aid flow from UN agencies (US$) of Botswana in 2005?
Offer a terse response. 5.30e+06. What is the difference between the Aid flow from UN agencies (US$) of Latin America(developing only) in 2004 and the Aid flow from UN agencies (US$) of Venezuela in 2005?
Provide a succinct answer. 5.52e+06. What is the difference between the Aid flow from UN agencies (US$) in Botswana in 2004 and the Aid flow from UN agencies (US$) in Venezuela in 2005?
Make the answer very short. 1.79e+06. What is the difference between the Aid flow from UN agencies (US$) in Europe(developing only) in 2004 and the Aid flow from UN agencies (US$) in Latin America(developing only) in 2009?
Offer a terse response. 5.21e+07. What is the difference between the Aid flow from UN agencies (US$) of Europe(developing only) in 2004 and the Aid flow from UN agencies (US$) of Botswana in 2009?
Your answer should be very brief. 6.15e+07. What is the difference between the Aid flow from UN agencies (US$) in Europe(developing only) in 2004 and the Aid flow from UN agencies (US$) in Venezuela in 2009?
Offer a terse response. 6.11e+07. What is the difference between the Aid flow from UN agencies (US$) of Latin America(developing only) in 2004 and the Aid flow from UN agencies (US$) of Botswana in 2009?
Make the answer very short. 4.93e+06. What is the difference between the Aid flow from UN agencies (US$) of Latin America(developing only) in 2004 and the Aid flow from UN agencies (US$) of Venezuela in 2009?
Your answer should be compact. 4.48e+06. What is the difference between the Aid flow from UN agencies (US$) in Botswana in 2004 and the Aid flow from UN agencies (US$) in Venezuela in 2009?
Your answer should be compact. 7.50e+05. What is the difference between the Aid flow from UN agencies (US$) in Europe(developing only) in 2005 and the Aid flow from UN agencies (US$) in Latin America(developing only) in 2009?
Offer a very short reply. 1.92e+07. What is the difference between the Aid flow from UN agencies (US$) in Europe(developing only) in 2005 and the Aid flow from UN agencies (US$) in Botswana in 2009?
Give a very brief answer. 2.86e+07. What is the difference between the Aid flow from UN agencies (US$) of Europe(developing only) in 2005 and the Aid flow from UN agencies (US$) of Venezuela in 2009?
Offer a terse response. 2.82e+07. What is the difference between the Aid flow from UN agencies (US$) in Latin America(developing only) in 2005 and the Aid flow from UN agencies (US$) in Botswana in 2009?
Your answer should be compact. 4.60e+06. What is the difference between the Aid flow from UN agencies (US$) in Latin America(developing only) in 2005 and the Aid flow from UN agencies (US$) in Venezuela in 2009?
Offer a terse response. 4.15e+06. What is the difference between the Aid flow from UN agencies (US$) in Botswana in 2005 and the Aid flow from UN agencies (US$) in Venezuela in 2009?
Make the answer very short. -8.20e+05. What is the average Aid flow from UN agencies (US$) in Europe(developing only) per year?
Provide a short and direct response. 7.42e+07. What is the average Aid flow from UN agencies (US$) in Latin America(developing only) per year?
Your answer should be compact. 1.16e+07. What is the average Aid flow from UN agencies (US$) of Botswana per year?
Offer a terse response. 1.33e+06. What is the average Aid flow from UN agencies (US$) in Venezuela per year?
Your answer should be compact. 1.12e+06. In the year 2000, what is the difference between the Aid flow from UN agencies (US$) of Europe(developing only) and Aid flow from UN agencies (US$) of Latin America(developing only)?
Your answer should be compact. 1.22e+08. In the year 2000, what is the difference between the Aid flow from UN agencies (US$) of Europe(developing only) and Aid flow from UN agencies (US$) of Botswana?
Offer a very short reply. 1.35e+08. In the year 2000, what is the difference between the Aid flow from UN agencies (US$) of Europe(developing only) and Aid flow from UN agencies (US$) of Venezuela?
Keep it short and to the point. 1.35e+08. In the year 2000, what is the difference between the Aid flow from UN agencies (US$) of Latin America(developing only) and Aid flow from UN agencies (US$) of Botswana?
Offer a terse response. 1.33e+07. In the year 2000, what is the difference between the Aid flow from UN agencies (US$) in Latin America(developing only) and Aid flow from UN agencies (US$) in Venezuela?
Your answer should be very brief. 1.32e+07. In the year 2001, what is the difference between the Aid flow from UN agencies (US$) of Europe(developing only) and Aid flow from UN agencies (US$) of Latin America(developing only)?
Give a very brief answer. 9.17e+07. In the year 2001, what is the difference between the Aid flow from UN agencies (US$) of Europe(developing only) and Aid flow from UN agencies (US$) of Botswana?
Ensure brevity in your answer.  1.05e+08. In the year 2001, what is the difference between the Aid flow from UN agencies (US$) in Europe(developing only) and Aid flow from UN agencies (US$) in Venezuela?
Provide a short and direct response. 1.05e+08. In the year 2001, what is the difference between the Aid flow from UN agencies (US$) of Latin America(developing only) and Aid flow from UN agencies (US$) of Botswana?
Provide a succinct answer. 1.33e+07. In the year 2001, what is the difference between the Aid flow from UN agencies (US$) in Latin America(developing only) and Aid flow from UN agencies (US$) in Venezuela?
Provide a short and direct response. 1.35e+07. In the year 2002, what is the difference between the Aid flow from UN agencies (US$) in Europe(developing only) and Aid flow from UN agencies (US$) in Latin America(developing only)?
Give a very brief answer. 7.51e+07. In the year 2002, what is the difference between the Aid flow from UN agencies (US$) in Europe(developing only) and Aid flow from UN agencies (US$) in Botswana?
Give a very brief answer. 8.92e+07. In the year 2002, what is the difference between the Aid flow from UN agencies (US$) in Europe(developing only) and Aid flow from UN agencies (US$) in Venezuela?
Provide a short and direct response. 8.92e+07. In the year 2002, what is the difference between the Aid flow from UN agencies (US$) of Latin America(developing only) and Aid flow from UN agencies (US$) of Botswana?
Provide a short and direct response. 1.41e+07. In the year 2002, what is the difference between the Aid flow from UN agencies (US$) in Latin America(developing only) and Aid flow from UN agencies (US$) in Venezuela?
Make the answer very short. 1.41e+07. In the year 2003, what is the difference between the Aid flow from UN agencies (US$) of Europe(developing only) and Aid flow from UN agencies (US$) of Latin America(developing only)?
Provide a short and direct response. 5.50e+07. In the year 2003, what is the difference between the Aid flow from UN agencies (US$) of Europe(developing only) and Aid flow from UN agencies (US$) of Botswana?
Your answer should be compact. 6.82e+07. In the year 2003, what is the difference between the Aid flow from UN agencies (US$) of Europe(developing only) and Aid flow from UN agencies (US$) of Venezuela?
Give a very brief answer. 6.84e+07. In the year 2003, what is the difference between the Aid flow from UN agencies (US$) in Latin America(developing only) and Aid flow from UN agencies (US$) in Botswana?
Your response must be concise. 1.32e+07. In the year 2003, what is the difference between the Aid flow from UN agencies (US$) of Latin America(developing only) and Aid flow from UN agencies (US$) of Venezuela?
Provide a succinct answer. 1.34e+07. In the year 2004, what is the difference between the Aid flow from UN agencies (US$) of Europe(developing only) and Aid flow from UN agencies (US$) of Latin America(developing only)?
Your answer should be compact. 5.66e+07. In the year 2004, what is the difference between the Aid flow from UN agencies (US$) of Europe(developing only) and Aid flow from UN agencies (US$) of Botswana?
Offer a terse response. 6.03e+07. In the year 2004, what is the difference between the Aid flow from UN agencies (US$) of Europe(developing only) and Aid flow from UN agencies (US$) of Venezuela?
Provide a short and direct response. 6.18e+07. In the year 2004, what is the difference between the Aid flow from UN agencies (US$) in Latin America(developing only) and Aid flow from UN agencies (US$) in Botswana?
Provide a succinct answer. 3.73e+06. In the year 2004, what is the difference between the Aid flow from UN agencies (US$) in Latin America(developing only) and Aid flow from UN agencies (US$) in Venezuela?
Offer a terse response. 5.24e+06. In the year 2004, what is the difference between the Aid flow from UN agencies (US$) of Botswana and Aid flow from UN agencies (US$) of Venezuela?
Provide a short and direct response. 1.51e+06. In the year 2005, what is the difference between the Aid flow from UN agencies (US$) of Europe(developing only) and Aid flow from UN agencies (US$) of Latin America(developing only)?
Offer a very short reply. 2.40e+07. In the year 2005, what is the difference between the Aid flow from UN agencies (US$) of Europe(developing only) and Aid flow from UN agencies (US$) of Botswana?
Your answer should be compact. 2.90e+07. In the year 2005, what is the difference between the Aid flow from UN agencies (US$) of Europe(developing only) and Aid flow from UN agencies (US$) of Venezuela?
Keep it short and to the point. 2.92e+07. In the year 2005, what is the difference between the Aid flow from UN agencies (US$) in Latin America(developing only) and Aid flow from UN agencies (US$) in Botswana?
Offer a very short reply. 4.97e+06. In the year 2005, what is the difference between the Aid flow from UN agencies (US$) in Latin America(developing only) and Aid flow from UN agencies (US$) in Venezuela?
Give a very brief answer. 5.19e+06. In the year 2005, what is the difference between the Aid flow from UN agencies (US$) of Botswana and Aid flow from UN agencies (US$) of Venezuela?
Your answer should be compact. 2.20e+05. In the year 2009, what is the difference between the Aid flow from UN agencies (US$) in Europe(developing only) and Aid flow from UN agencies (US$) in Latin America(developing only)?
Your answer should be very brief. 1.41e+07. In the year 2009, what is the difference between the Aid flow from UN agencies (US$) in Europe(developing only) and Aid flow from UN agencies (US$) in Botswana?
Give a very brief answer. 2.35e+07. In the year 2009, what is the difference between the Aid flow from UN agencies (US$) of Europe(developing only) and Aid flow from UN agencies (US$) of Venezuela?
Your answer should be compact. 2.31e+07. In the year 2009, what is the difference between the Aid flow from UN agencies (US$) in Latin America(developing only) and Aid flow from UN agencies (US$) in Botswana?
Give a very brief answer. 9.42e+06. In the year 2009, what is the difference between the Aid flow from UN agencies (US$) in Latin America(developing only) and Aid flow from UN agencies (US$) in Venezuela?
Keep it short and to the point. 8.97e+06. In the year 2009, what is the difference between the Aid flow from UN agencies (US$) of Botswana and Aid flow from UN agencies (US$) of Venezuela?
Give a very brief answer. -4.50e+05. What is the ratio of the Aid flow from UN agencies (US$) of Europe(developing only) in 2000 to that in 2001?
Provide a short and direct response. 1.28. What is the ratio of the Aid flow from UN agencies (US$) of Latin America(developing only) in 2000 to that in 2001?
Make the answer very short. 0.95. What is the ratio of the Aid flow from UN agencies (US$) of Botswana in 2000 to that in 2001?
Your answer should be very brief. 0.53. What is the ratio of the Aid flow from UN agencies (US$) in Venezuela in 2000 to that in 2001?
Offer a very short reply. 0.72. What is the ratio of the Aid flow from UN agencies (US$) in Europe(developing only) in 2000 to that in 2002?
Provide a succinct answer. 1.5. What is the ratio of the Aid flow from UN agencies (US$) in Latin America(developing only) in 2000 to that in 2002?
Offer a terse response. 0.91. What is the ratio of the Aid flow from UN agencies (US$) in Botswana in 2000 to that in 2002?
Provide a succinct answer. 0.55. What is the ratio of the Aid flow from UN agencies (US$) of Venezuela in 2000 to that in 2002?
Provide a short and direct response. 0.64. What is the ratio of the Aid flow from UN agencies (US$) in Europe(developing only) in 2000 to that in 2003?
Make the answer very short. 1.95. What is the ratio of the Aid flow from UN agencies (US$) in Latin America(developing only) in 2000 to that in 2003?
Your response must be concise. 0.97. What is the ratio of the Aid flow from UN agencies (US$) in Botswana in 2000 to that in 2003?
Make the answer very short. 0.58. What is the ratio of the Aid flow from UN agencies (US$) in Venezuela in 2000 to that in 2003?
Offer a terse response. 0.78. What is the ratio of the Aid flow from UN agencies (US$) of Europe(developing only) in 2000 to that in 2004?
Offer a very short reply. 2.17. What is the ratio of the Aid flow from UN agencies (US$) of Latin America(developing only) in 2000 to that in 2004?
Your response must be concise. 2.4. What is the ratio of the Aid flow from UN agencies (US$) of Botswana in 2000 to that in 2004?
Make the answer very short. 0.39. What is the ratio of the Aid flow from UN agencies (US$) in Venezuela in 2000 to that in 2004?
Offer a terse response. 1.52. What is the ratio of the Aid flow from UN agencies (US$) in Europe(developing only) in 2000 to that in 2005?
Give a very brief answer. 4.59. What is the ratio of the Aid flow from UN agencies (US$) of Latin America(developing only) in 2000 to that in 2005?
Provide a short and direct response. 2.54. What is the ratio of the Aid flow from UN agencies (US$) of Botswana in 2000 to that in 2005?
Ensure brevity in your answer.  1.41. What is the ratio of the Aid flow from UN agencies (US$) in Venezuela in 2000 to that in 2005?
Offer a very short reply. 2.62. What is the ratio of the Aid flow from UN agencies (US$) in Europe(developing only) in 2000 to that in 2009?
Ensure brevity in your answer.  5.55. What is the ratio of the Aid flow from UN agencies (US$) in Latin America(developing only) in 2000 to that in 2009?
Offer a very short reply. 1.36. What is the ratio of the Aid flow from UN agencies (US$) of Botswana in 2000 to that in 2009?
Offer a terse response. 0.88. What is the ratio of the Aid flow from UN agencies (US$) of Venezuela in 2000 to that in 2009?
Give a very brief answer. 0.71. What is the ratio of the Aid flow from UN agencies (US$) of Europe(developing only) in 2001 to that in 2002?
Your answer should be compact. 1.17. What is the ratio of the Aid flow from UN agencies (US$) in Latin America(developing only) in 2001 to that in 2002?
Your answer should be compact. 0.95. What is the ratio of the Aid flow from UN agencies (US$) in Botswana in 2001 to that in 2002?
Ensure brevity in your answer.  1.05. What is the ratio of the Aid flow from UN agencies (US$) of Venezuela in 2001 to that in 2002?
Your response must be concise. 0.88. What is the ratio of the Aid flow from UN agencies (US$) in Europe(developing only) in 2001 to that in 2003?
Offer a very short reply. 1.53. What is the ratio of the Aid flow from UN agencies (US$) in Latin America(developing only) in 2001 to that in 2003?
Make the answer very short. 1.01. What is the ratio of the Aid flow from UN agencies (US$) in Botswana in 2001 to that in 2003?
Offer a very short reply. 1.09. What is the ratio of the Aid flow from UN agencies (US$) in Venezuela in 2001 to that in 2003?
Your response must be concise. 1.08. What is the ratio of the Aid flow from UN agencies (US$) in Europe(developing only) in 2001 to that in 2004?
Make the answer very short. 1.7. What is the ratio of the Aid flow from UN agencies (US$) in Latin America(developing only) in 2001 to that in 2004?
Provide a short and direct response. 2.52. What is the ratio of the Aid flow from UN agencies (US$) in Botswana in 2001 to that in 2004?
Offer a terse response. 0.74. What is the ratio of the Aid flow from UN agencies (US$) in Venezuela in 2001 to that in 2004?
Provide a succinct answer. 2.1. What is the ratio of the Aid flow from UN agencies (US$) in Europe(developing only) in 2001 to that in 2005?
Your answer should be very brief. 3.6. What is the ratio of the Aid flow from UN agencies (US$) in Latin America(developing only) in 2001 to that in 2005?
Give a very brief answer. 2.67. What is the ratio of the Aid flow from UN agencies (US$) of Botswana in 2001 to that in 2005?
Ensure brevity in your answer.  2.66. What is the ratio of the Aid flow from UN agencies (US$) of Venezuela in 2001 to that in 2005?
Ensure brevity in your answer.  3.62. What is the ratio of the Aid flow from UN agencies (US$) in Europe(developing only) in 2001 to that in 2009?
Keep it short and to the point. 4.35. What is the ratio of the Aid flow from UN agencies (US$) of Latin America(developing only) in 2001 to that in 2009?
Provide a short and direct response. 1.43. What is the ratio of the Aid flow from UN agencies (US$) in Botswana in 2001 to that in 2009?
Offer a very short reply. 1.65. What is the ratio of the Aid flow from UN agencies (US$) of Europe(developing only) in 2002 to that in 2003?
Give a very brief answer. 1.3. What is the ratio of the Aid flow from UN agencies (US$) of Latin America(developing only) in 2002 to that in 2003?
Provide a short and direct response. 1.07. What is the ratio of the Aid flow from UN agencies (US$) of Botswana in 2002 to that in 2003?
Your answer should be compact. 1.05. What is the ratio of the Aid flow from UN agencies (US$) of Venezuela in 2002 to that in 2003?
Ensure brevity in your answer.  1.22. What is the ratio of the Aid flow from UN agencies (US$) in Europe(developing only) in 2002 to that in 2004?
Give a very brief answer. 1.45. What is the ratio of the Aid flow from UN agencies (US$) in Latin America(developing only) in 2002 to that in 2004?
Provide a succinct answer. 2.65. What is the ratio of the Aid flow from UN agencies (US$) in Botswana in 2002 to that in 2004?
Your response must be concise. 0.71. What is the ratio of the Aid flow from UN agencies (US$) of Venezuela in 2002 to that in 2004?
Offer a very short reply. 2.39. What is the ratio of the Aid flow from UN agencies (US$) in Europe(developing only) in 2002 to that in 2005?
Give a very brief answer. 3.07. What is the ratio of the Aid flow from UN agencies (US$) in Latin America(developing only) in 2002 to that in 2005?
Ensure brevity in your answer.  2.81. What is the ratio of the Aid flow from UN agencies (US$) of Botswana in 2002 to that in 2005?
Offer a very short reply. 2.54. What is the ratio of the Aid flow from UN agencies (US$) of Venezuela in 2002 to that in 2005?
Provide a short and direct response. 4.1. What is the ratio of the Aid flow from UN agencies (US$) in Europe(developing only) in 2002 to that in 2009?
Give a very brief answer. 3.71. What is the ratio of the Aid flow from UN agencies (US$) in Latin America(developing only) in 2002 to that in 2009?
Your answer should be very brief. 1.51. What is the ratio of the Aid flow from UN agencies (US$) in Botswana in 2002 to that in 2009?
Give a very brief answer. 1.58. What is the ratio of the Aid flow from UN agencies (US$) of Venezuela in 2002 to that in 2009?
Offer a terse response. 1.12. What is the ratio of the Aid flow from UN agencies (US$) of Europe(developing only) in 2003 to that in 2004?
Your answer should be compact. 1.11. What is the ratio of the Aid flow from UN agencies (US$) in Latin America(developing only) in 2003 to that in 2004?
Provide a succinct answer. 2.48. What is the ratio of the Aid flow from UN agencies (US$) in Botswana in 2003 to that in 2004?
Keep it short and to the point. 0.68. What is the ratio of the Aid flow from UN agencies (US$) in Venezuela in 2003 to that in 2004?
Your answer should be compact. 1.96. What is the ratio of the Aid flow from UN agencies (US$) of Europe(developing only) in 2003 to that in 2005?
Give a very brief answer. 2.35. What is the ratio of the Aid flow from UN agencies (US$) of Latin America(developing only) in 2003 to that in 2005?
Keep it short and to the point. 2.63. What is the ratio of the Aid flow from UN agencies (US$) of Botswana in 2003 to that in 2005?
Give a very brief answer. 2.43. What is the ratio of the Aid flow from UN agencies (US$) in Venezuela in 2003 to that in 2005?
Offer a very short reply. 3.36. What is the ratio of the Aid flow from UN agencies (US$) of Europe(developing only) in 2003 to that in 2009?
Offer a very short reply. 2.84. What is the ratio of the Aid flow from UN agencies (US$) in Latin America(developing only) in 2003 to that in 2009?
Your answer should be very brief. 1.41. What is the ratio of the Aid flow from UN agencies (US$) in Botswana in 2003 to that in 2009?
Provide a succinct answer. 1.51. What is the ratio of the Aid flow from UN agencies (US$) of Venezuela in 2003 to that in 2009?
Your response must be concise. 0.92. What is the ratio of the Aid flow from UN agencies (US$) of Europe(developing only) in 2004 to that in 2005?
Provide a succinct answer. 2.11. What is the ratio of the Aid flow from UN agencies (US$) of Latin America(developing only) in 2004 to that in 2005?
Make the answer very short. 1.06. What is the ratio of the Aid flow from UN agencies (US$) of Botswana in 2004 to that in 2005?
Provide a succinct answer. 3.57. What is the ratio of the Aid flow from UN agencies (US$) in Venezuela in 2004 to that in 2005?
Offer a very short reply. 1.72. What is the ratio of the Aid flow from UN agencies (US$) of Europe(developing only) in 2004 to that in 2009?
Provide a succinct answer. 2.55. What is the ratio of the Aid flow from UN agencies (US$) of Latin America(developing only) in 2004 to that in 2009?
Offer a terse response. 0.57. What is the ratio of the Aid flow from UN agencies (US$) of Botswana in 2004 to that in 2009?
Offer a terse response. 2.22. What is the ratio of the Aid flow from UN agencies (US$) in Venezuela in 2004 to that in 2009?
Your answer should be very brief. 0.47. What is the ratio of the Aid flow from UN agencies (US$) in Europe(developing only) in 2005 to that in 2009?
Ensure brevity in your answer.  1.21. What is the ratio of the Aid flow from UN agencies (US$) in Latin America(developing only) in 2005 to that in 2009?
Your response must be concise. 0.54. What is the ratio of the Aid flow from UN agencies (US$) of Botswana in 2005 to that in 2009?
Give a very brief answer. 0.62. What is the ratio of the Aid flow from UN agencies (US$) of Venezuela in 2005 to that in 2009?
Keep it short and to the point. 0.27. What is the difference between the highest and the second highest Aid flow from UN agencies (US$) of Europe(developing only)?
Provide a succinct answer. 2.93e+07. What is the difference between the highest and the second highest Aid flow from UN agencies (US$) of Latin America(developing only)?
Your answer should be compact. 7.60e+05. What is the difference between the highest and the second highest Aid flow from UN agencies (US$) of Botswana?
Provide a succinct answer. 5.60e+05. What is the difference between the highest and the second highest Aid flow from UN agencies (US$) of Venezuela?
Your response must be concise. 1.70e+05. What is the difference between the highest and the lowest Aid flow from UN agencies (US$) of Europe(developing only)?
Your answer should be very brief. 1.11e+08. What is the difference between the highest and the lowest Aid flow from UN agencies (US$) in Latin America(developing only)?
Your answer should be compact. 1.01e+07. What is the difference between the highest and the lowest Aid flow from UN agencies (US$) of Botswana?
Your answer should be very brief. 1.57e+06. What is the difference between the highest and the lowest Aid flow from UN agencies (US$) of Venezuela?
Keep it short and to the point. 1.21e+06. 